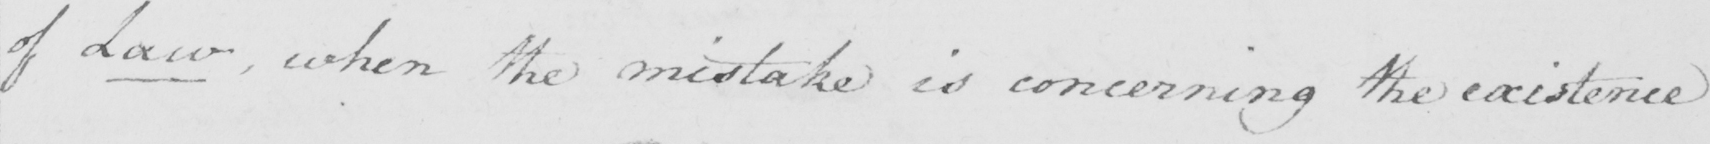Please provide the text content of this handwritten line. of Law , when the mistake is concerning the existence 